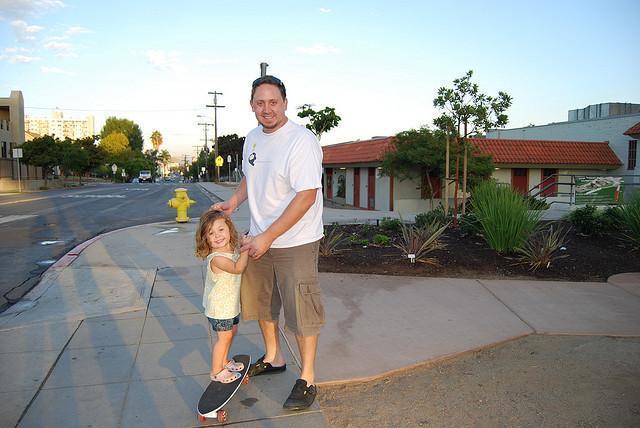How many of their shirts have blue in them?
Give a very brief answer. 0. How many people can you see?
Give a very brief answer. 2. 